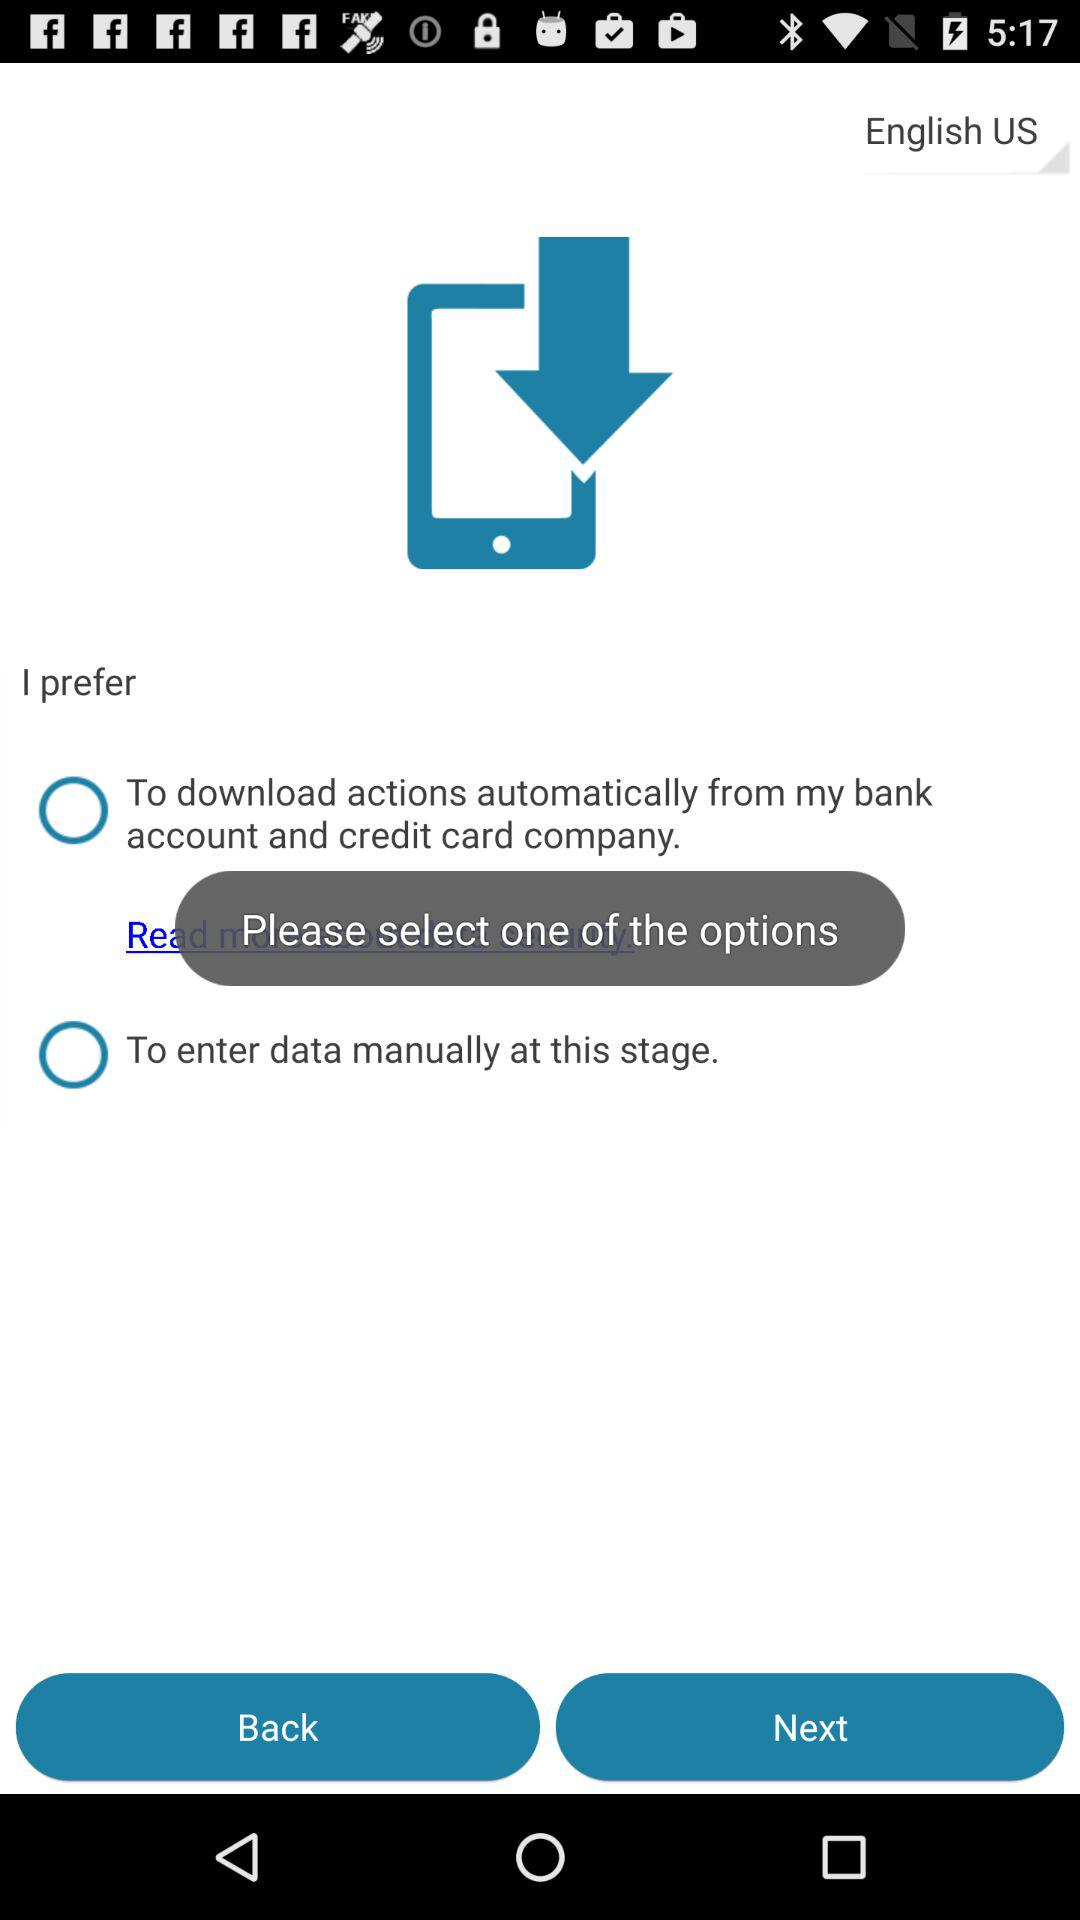Which language has been chosen? The chosen language is English (US). 